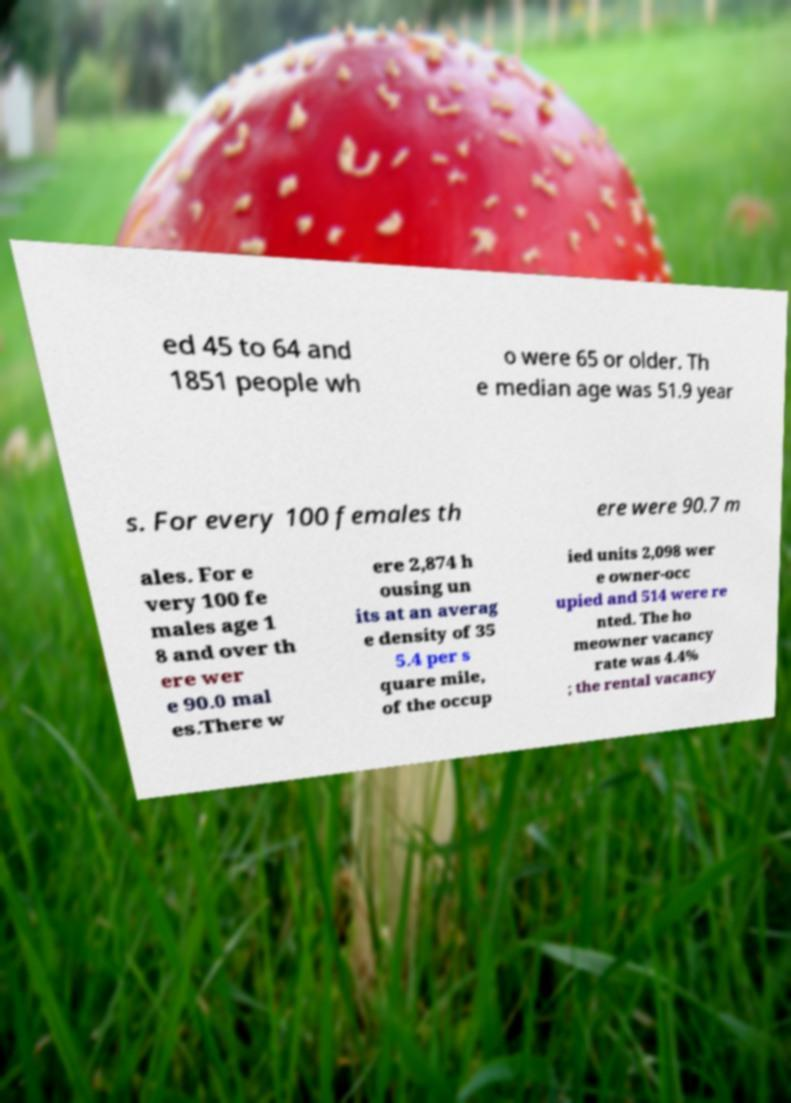Can you accurately transcribe the text from the provided image for me? ed 45 to 64 and 1851 people wh o were 65 or older. Th e median age was 51.9 year s. For every 100 females th ere were 90.7 m ales. For e very 100 fe males age 1 8 and over th ere wer e 90.0 mal es.There w ere 2,874 h ousing un its at an averag e density of 35 5.4 per s quare mile, of the occup ied units 2,098 wer e owner-occ upied and 514 were re nted. The ho meowner vacancy rate was 4.4% ; the rental vacancy 